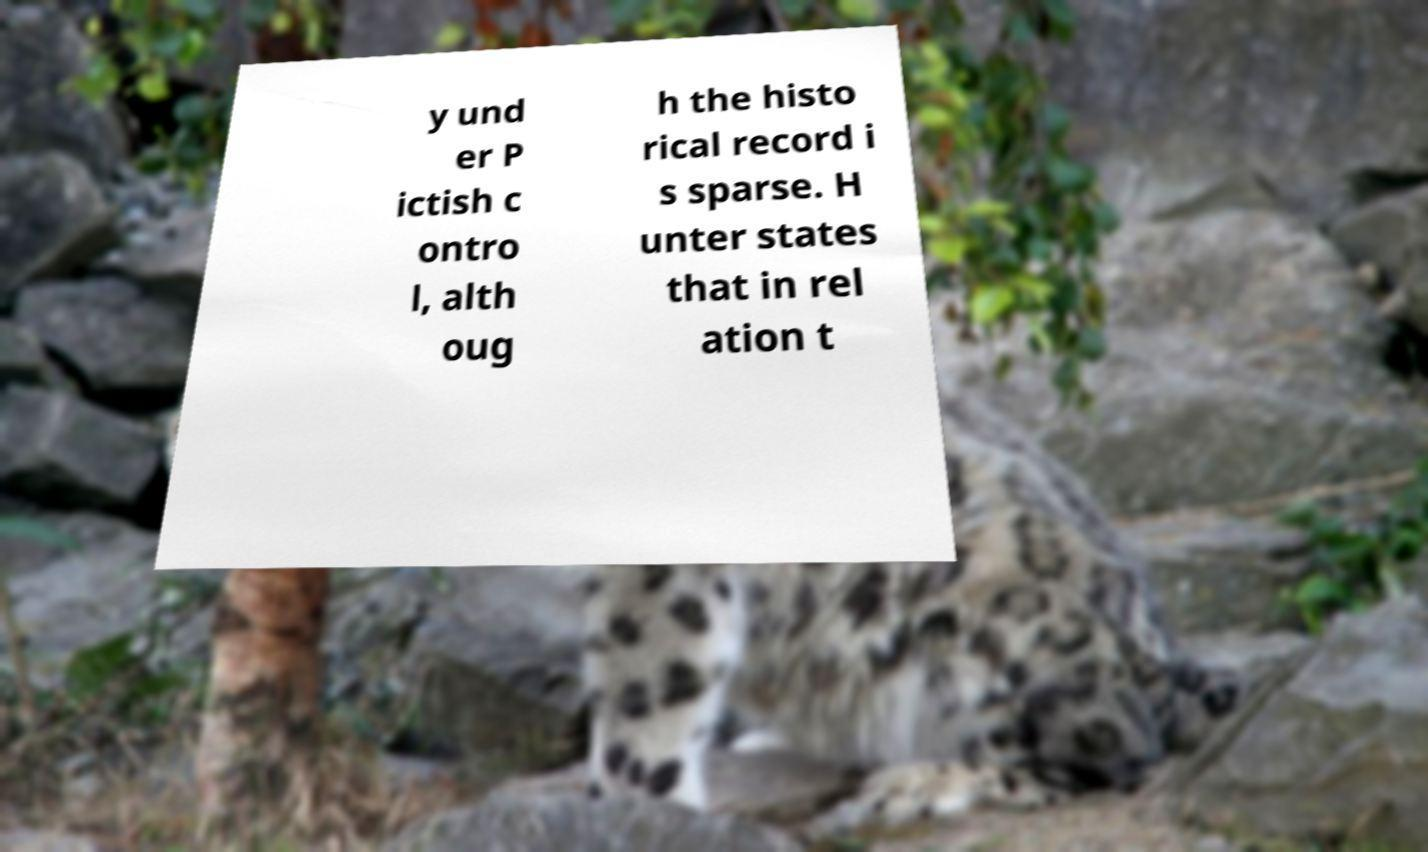Can you read and provide the text displayed in the image?This photo seems to have some interesting text. Can you extract and type it out for me? y und er P ictish c ontro l, alth oug h the histo rical record i s sparse. H unter states that in rel ation t 